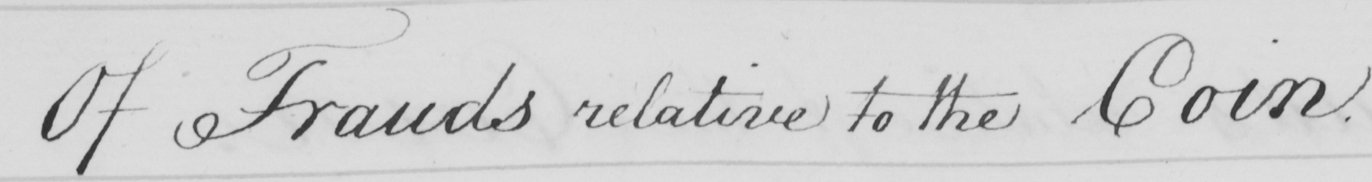What text is written in this handwritten line? Of Frauds relative to the Coin . 